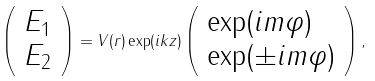Convert formula to latex. <formula><loc_0><loc_0><loc_500><loc_500>\left ( \begin{array} { l } E _ { 1 } \\ E _ { 2 } \end{array} \right ) = V ( r ) \exp ( i k z ) \left ( \begin{array} { l } \exp ( i m \varphi ) \\ \exp ( \pm i m \varphi ) \end{array} \right ) ,</formula> 